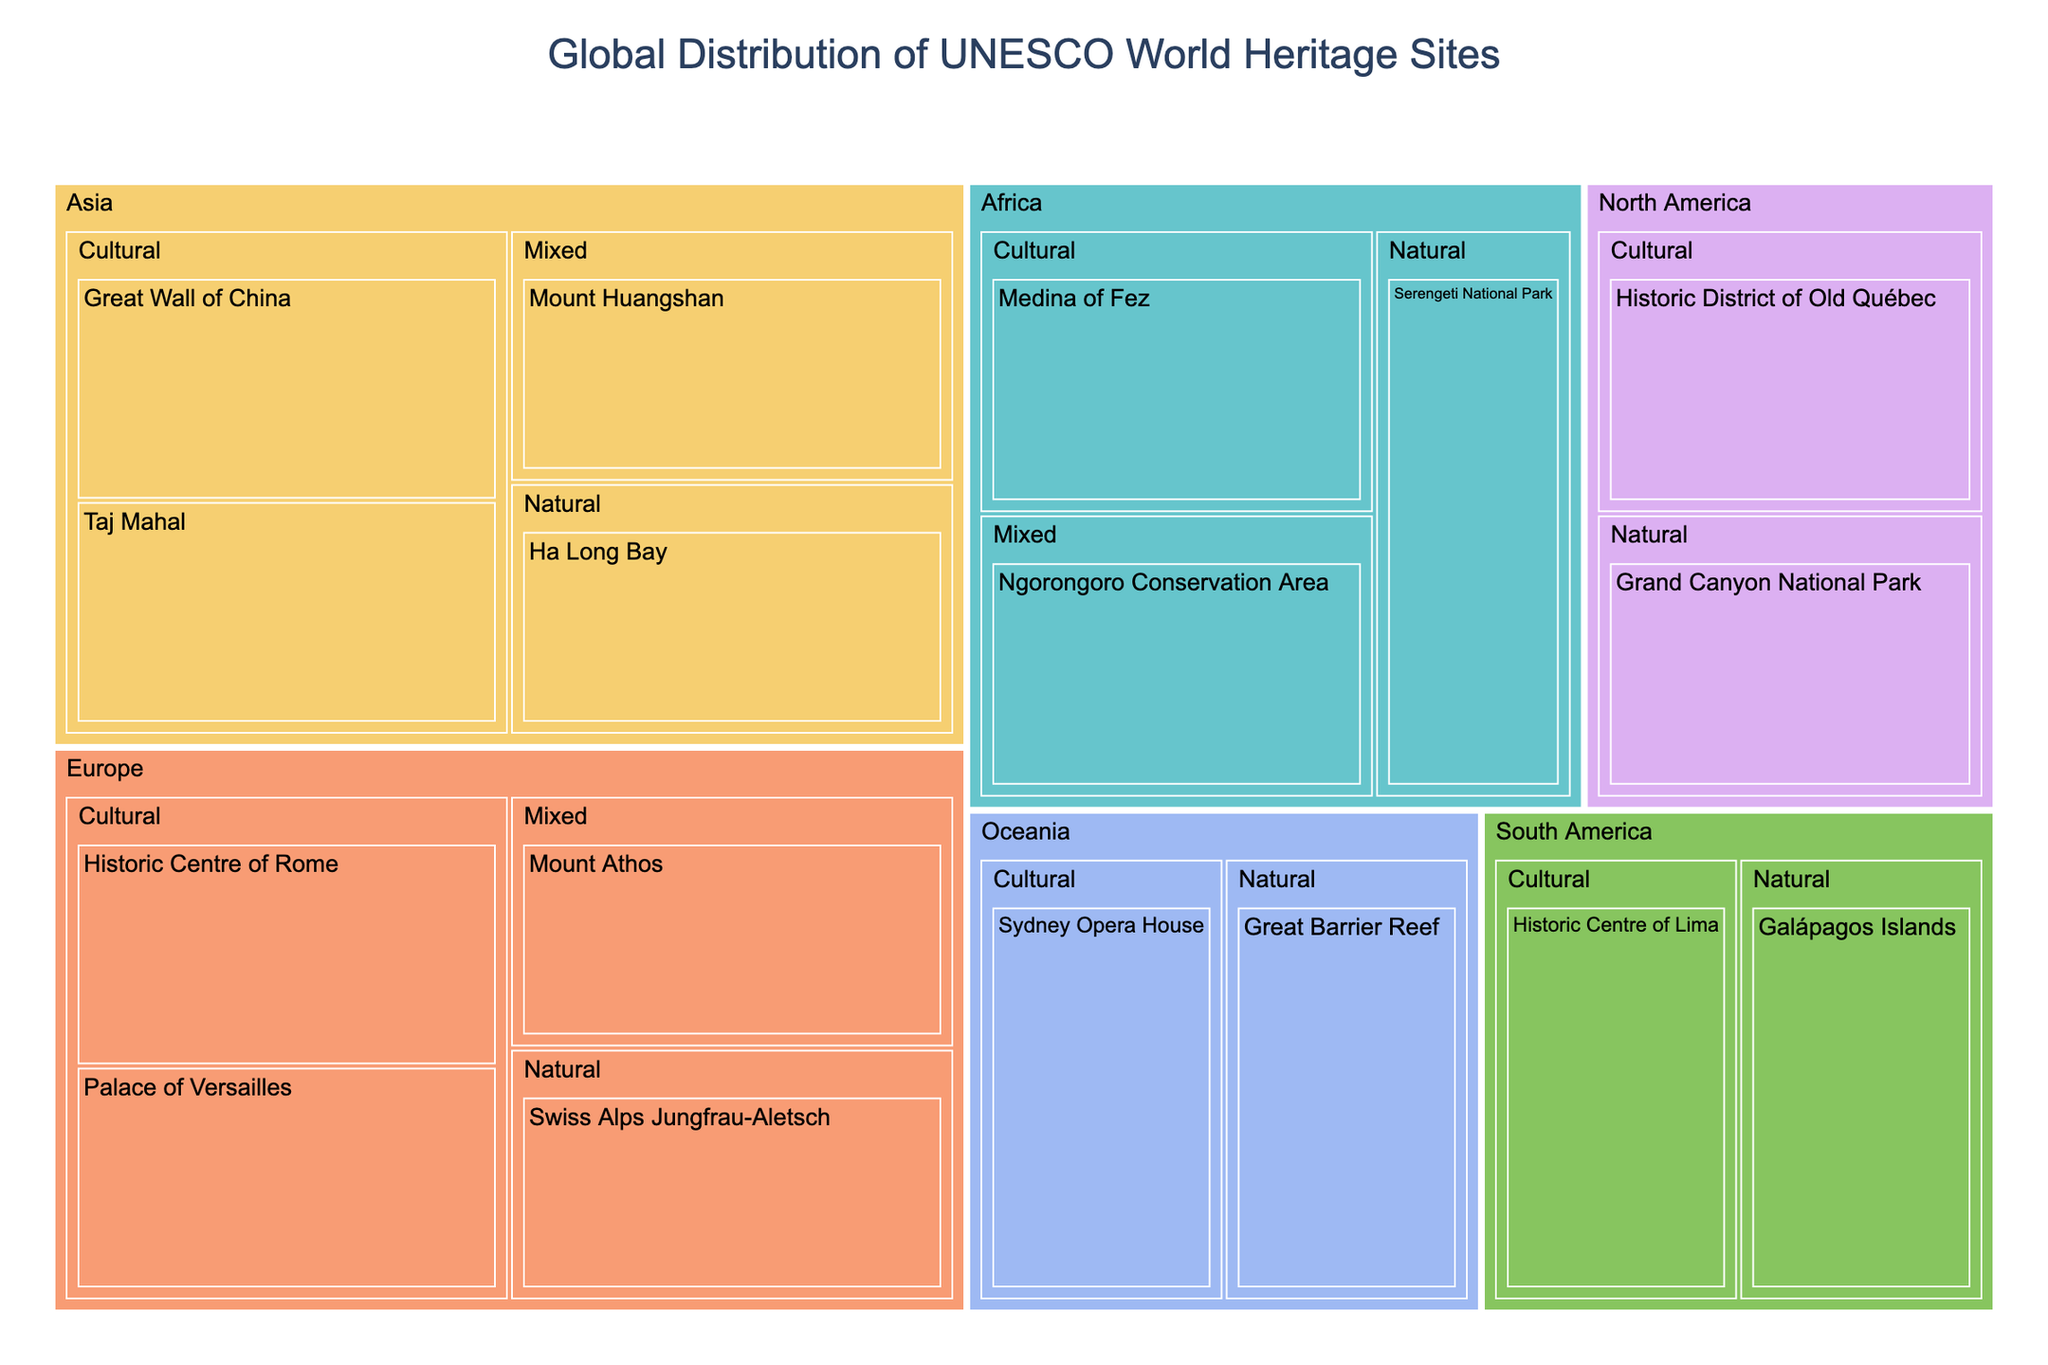What's the title of the treemap? The title is displayed at the top of the figure, centrally aligned.
Answer: Global Distribution of UNESCO World Heritage Sites Which region has the most types of UNESCO World Heritage Sites? By looking at the color-coded regions and the different types within each region, Europe appears to have all three types: Cultural, Natural, and Mixed.
Answer: Europe How many Cultural Heritage Sites are listed in Asia? Look at the branches under Asia and count the ones with "Cultural" type. There are two: Great Wall of China and Taj Mahal.
Answer: 2 Which region has the UNESCO World Heritage Site "Serengeti National Park"? Locate the site "Serengeti National Park" and identify its parent region.
Answer: Africa Between the Natural Heritage Sites, which one is located in Oceania? Look under the Oceania region and find the site with the "Natural" type.
Answer: Great Barrier Reef How does the number of Cultural Heritage Sites in Europe compare to those in North America? Count the Cultural Heritage Sites in both Europe (Historic Centre of Rome, Palace of Versailles) and North America (Historic District of Old Québec). Europe has 2, and North America has 1.
Answer: Europe has 1 more Cultural site than North America Combine the total number of Mixed Heritage Sites in Africa and Asia. There is 1 Mixed site in Africa (Ngorongoro Conservation Area) and 1 Mixed site in Asia (Mount Huangshan). Sum them together.
Answer: 2 What is the only region with just one site, and what type is it? Identify the region with only one site by scanning through the regions. Oceania has one site, which is Natural, identified as Great Barrier Reef.
Answer: Oceania, Natural By visual inspection, which region has fewer sites: South America or Oceania? Compare the number of sites within each color-coded region. South America has 2 sites (Historic Centre of Lima and Galápagos Islands), while Oceania has 2 sites (Sydney Opera House and Great Barrier Reef).
Answer: Both have 2 sites What are the names of all Natural Heritage Sites listed in North America and South America? Identify the Natural type under both North America and South America. North America has Grand Canyon National Park, and South America has Galápagos Islands.
Answer: Grand Canyon National Park, Galápagos Islands 